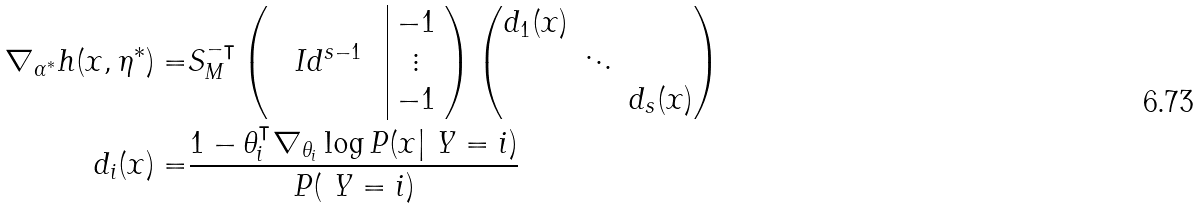<formula> <loc_0><loc_0><loc_500><loc_500>\nabla _ { \alpha ^ { * } } h ( x , \eta ^ { * } ) = & S _ { M } ^ { - \intercal } \left ( \begin{array} { c c c | c } & & & - 1 \\ & I d ^ { s - 1 } & & \vdots \\ & & & - 1 \\ \end{array} \right ) \begin{pmatrix} d _ { 1 } ( x ) \\ & \ddots \\ & & d _ { s } ( x ) \end{pmatrix} \\ d _ { i } ( x ) = & \frac { 1 - \theta _ { i } ^ { \intercal } \nabla _ { \theta _ { i } } \log P ( x | \ Y = i ) } { P ( \ Y = i ) }</formula> 